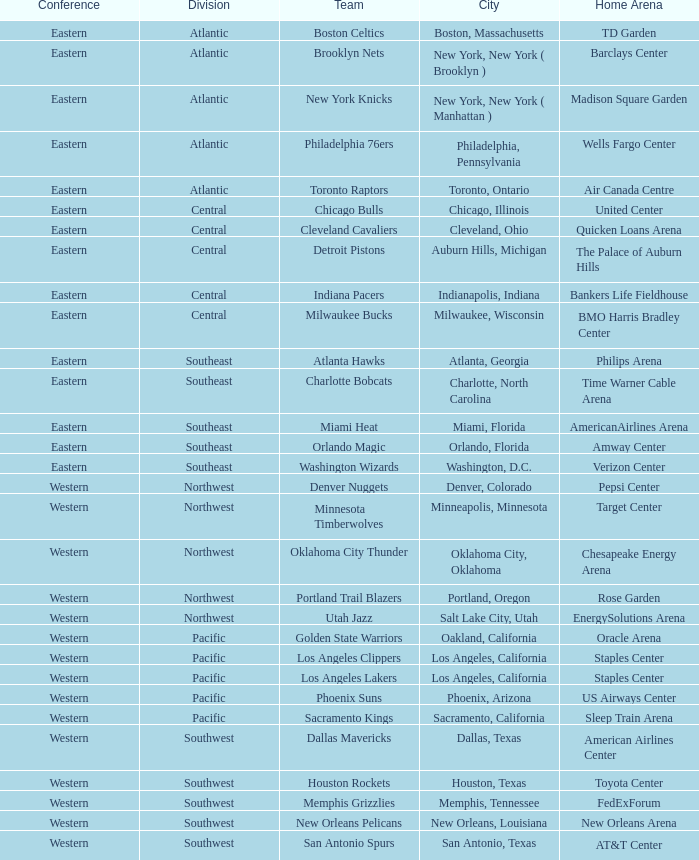Which division do the Toronto Raptors belong in? Atlantic. 